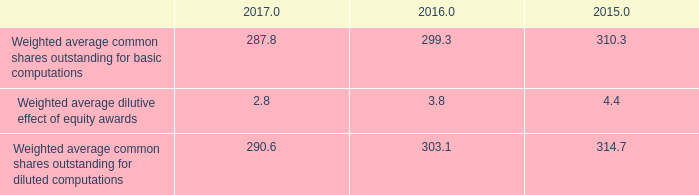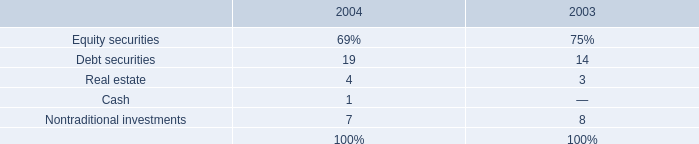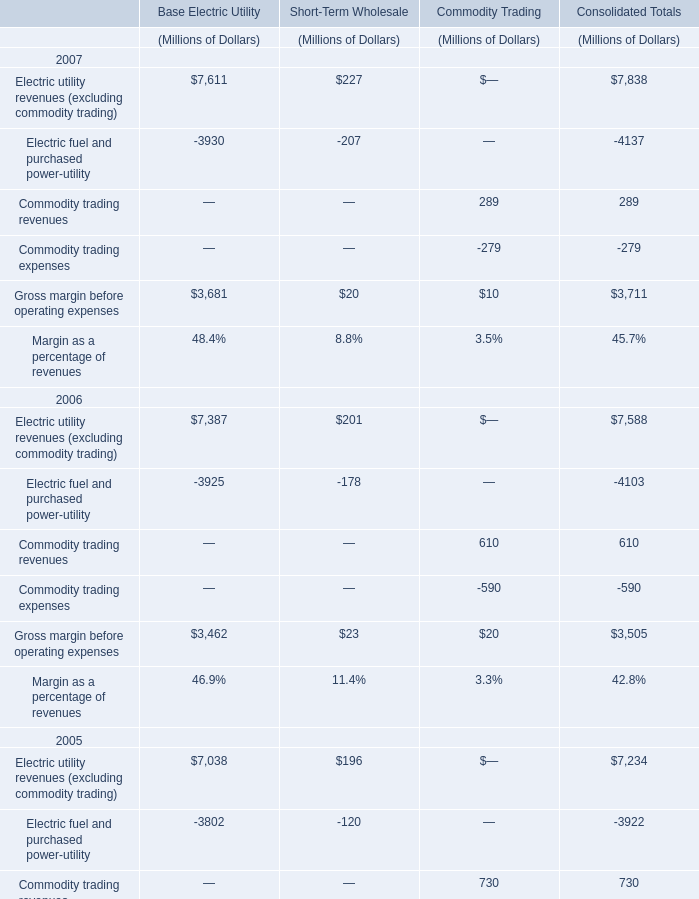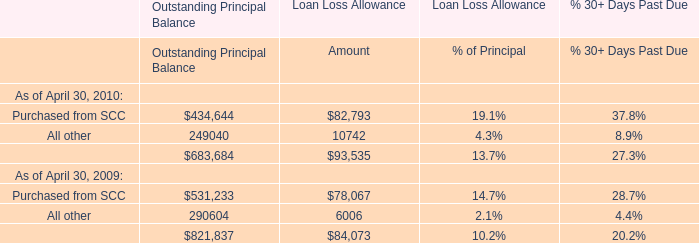What's the sum of all Outstanding Principal Balance that are greater than 200000 in 2010? 
Computations: (434644 + 249040)
Answer: 683684.0. 